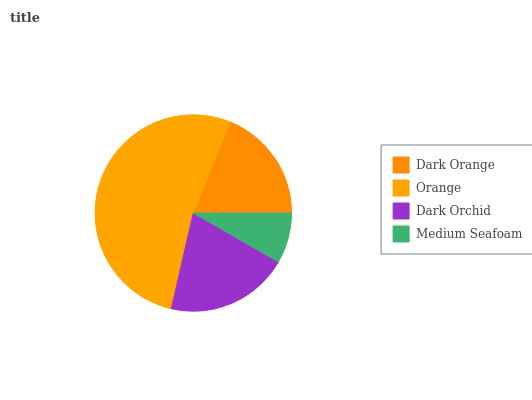Is Medium Seafoam the minimum?
Answer yes or no. Yes. Is Orange the maximum?
Answer yes or no. Yes. Is Dark Orchid the minimum?
Answer yes or no. No. Is Dark Orchid the maximum?
Answer yes or no. No. Is Orange greater than Dark Orchid?
Answer yes or no. Yes. Is Dark Orchid less than Orange?
Answer yes or no. Yes. Is Dark Orchid greater than Orange?
Answer yes or no. No. Is Orange less than Dark Orchid?
Answer yes or no. No. Is Dark Orchid the high median?
Answer yes or no. Yes. Is Dark Orange the low median?
Answer yes or no. Yes. Is Orange the high median?
Answer yes or no. No. Is Dark Orchid the low median?
Answer yes or no. No. 